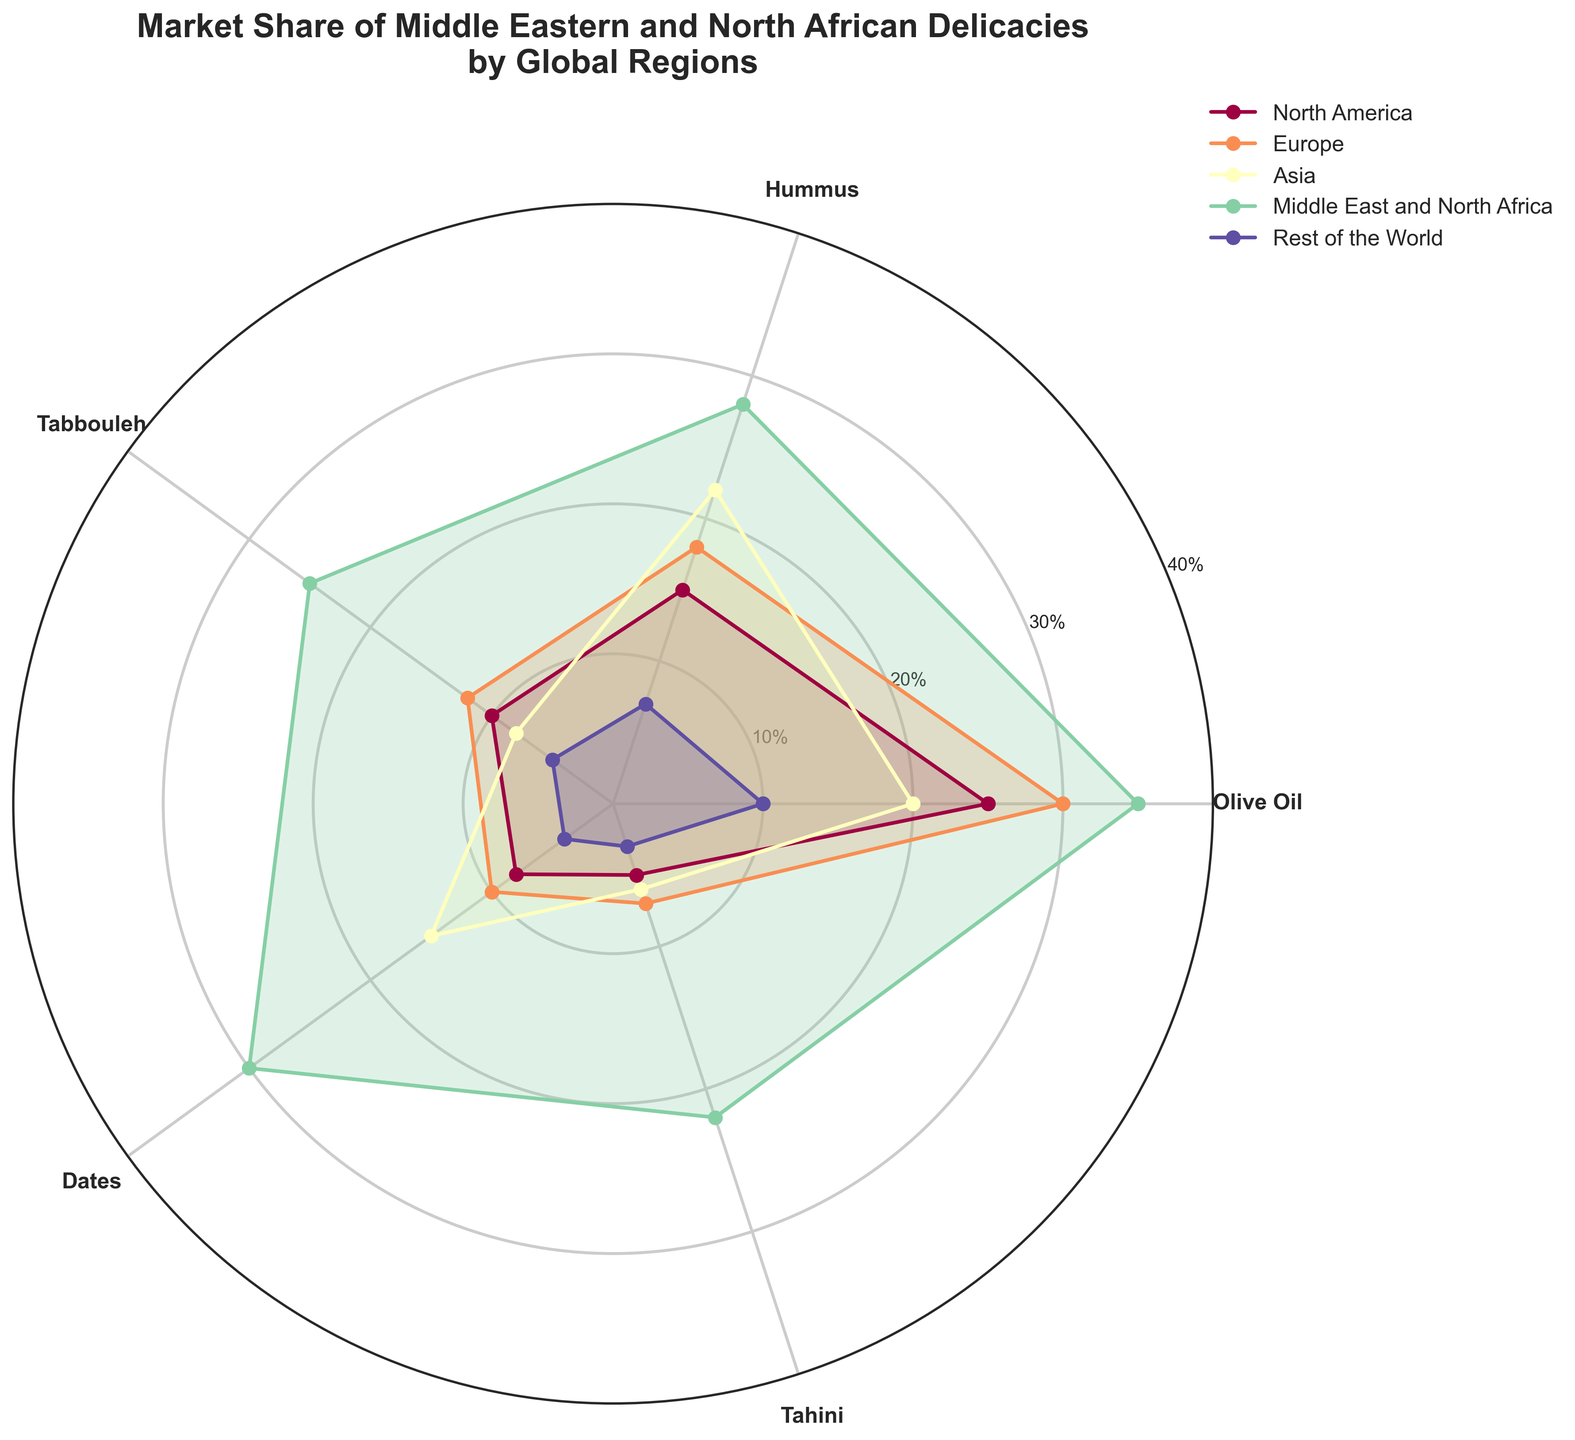What is the title of the plot? The title is visible at the top of the plot and it reads "Market Share of Middle Eastern and North African Delicacies by Global Regions."
Answer: Market Share of Middle Eastern and North African Delicacies by Global Regions Which region has the highest market share of Hummus? By examining the plot and locating the Hummus label, you can see that the highest point is for the Middle East and North Africa region.
Answer: Middle East and North Africa What is the market share of Tabbouleh in Europe? Look at the plot, find the Tabbouleh label, and trace the corresponding value for Europe, which is slightly above 10%.
Answer: 12% Which delicacy has the smallest market share in the Rest of the World? For Rest of the World, find the smallest value among the delicacies, which is Tahini with a 3% share.
Answer: Tahini How does the market share of Dates in Asia compare to that in North America? Find the Dates label, then compare the values of Asia and North America, where Asia has a higher market share (15%) than North America (8%).
Answer: Asia has a higher market share than North America Which delicacy has the highest average market share across all regions? Calculate the average for each delicacy across all regions: 
- Olive Oil: (25+30+20+35+10)/5 = 24%
- Hummus: (15+18+22+28+7)/5 = 18%
- Tabbouleh: (10+12+8+25+5)/5 = 12%
- Dates: (8+10+15+30+4)/5 = 13.4%
- Tahini: (5+7+6+22+3)/5 = 8.6%. Thus, Olive Oil has the highest average market share.
Answer: Olive Oil What is the total market share of Olive Oil in all regions combined? Sum the market share of Olive Oil from all regions: 25 + 30 + 20 + 35 + 10 = 120
Answer: 120% Which region has the most even distribution of market share among the delicacies? An even distribution would reflect similar market shares for all delicacies in a region. By observing the spread for each region, the Rest of the World shows the most even distribution with slight variations.
Answer: Rest of the World What is the difference in market share for Tahini between Middle East and North Africa and Europe? Subtract the Tahini market share for Europe from that of Middle East and North Africa: 22 - 7 = 15
Answer: 15% What is the median market share of delicacies in North America? Sort the market shares in North America (25, 15, 10, 8, 5) and find the middle value: 10
Answer: 10% 